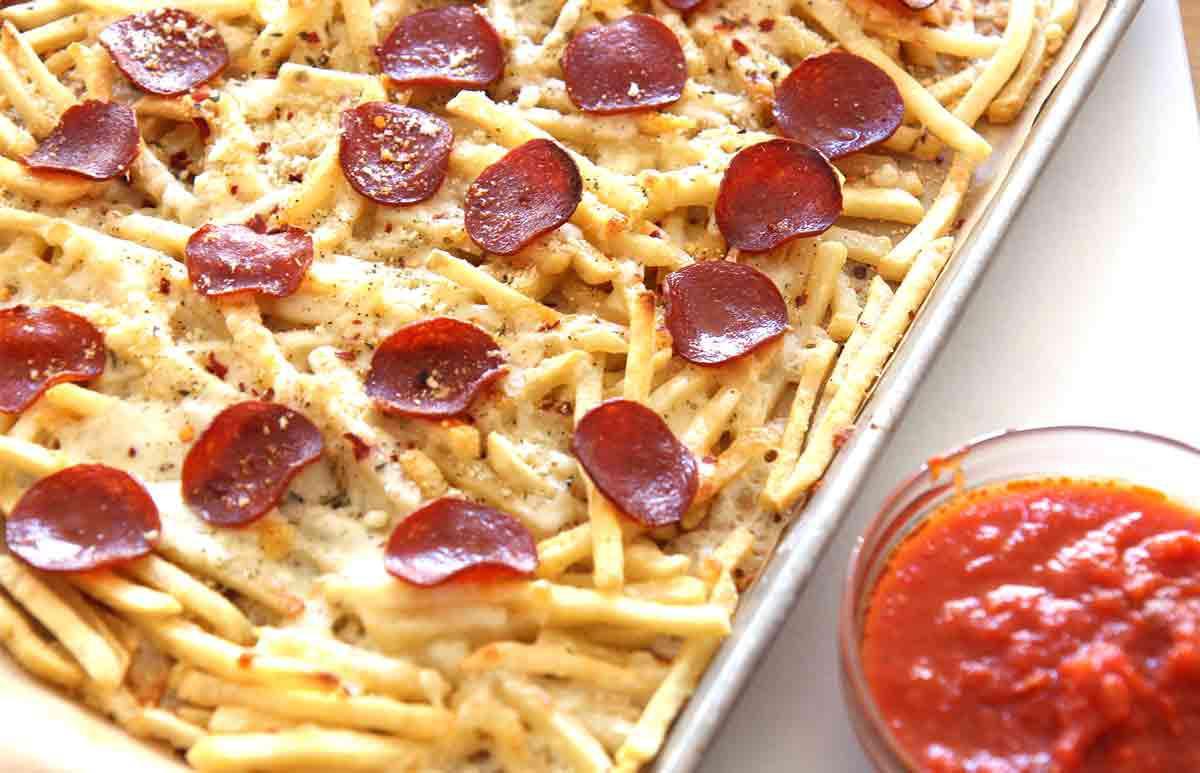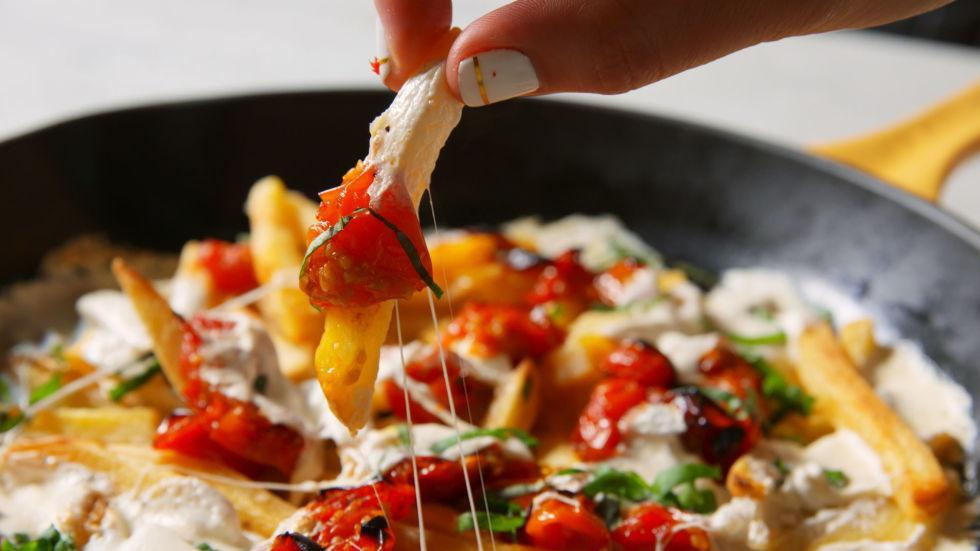The first image is the image on the left, the second image is the image on the right. Evaluate the accuracy of this statement regarding the images: "The right image contains one order of pizza fries and one ramekin of marinara.". Is it true? Answer yes or no. No. The first image is the image on the left, the second image is the image on the right. For the images shown, is this caption "The left image shows a round bowl of red-orange sauce next to but not touching a rectangular pan containing french fries with pepperonis on top." true? Answer yes or no. Yes. 